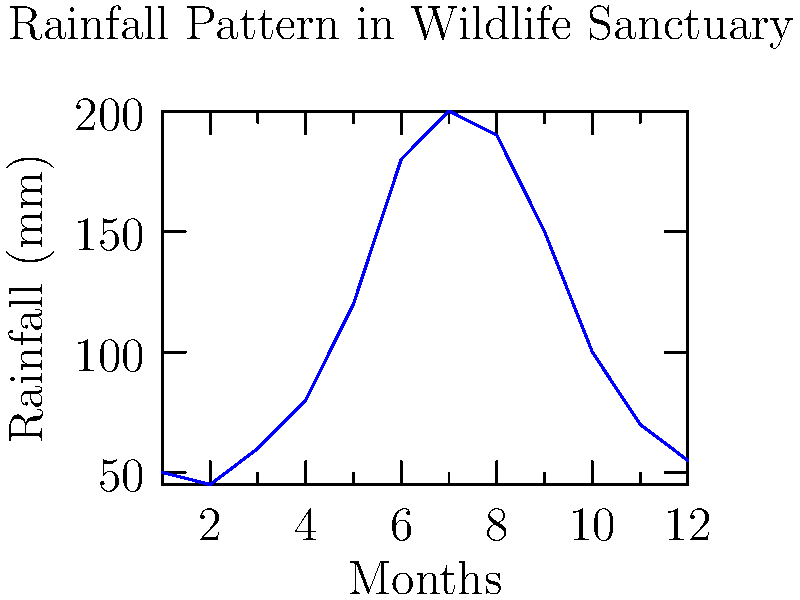Based on the line graph showing the rainfall pattern in the wildlife sanctuary, during which month does the sanctuary experience the highest rainfall? How might this peak rainfall affect the wildlife and ecosystem management strategies? To answer this question, we need to follow these steps:

1. Examine the line graph carefully, focusing on the y-axis (Rainfall in mm) and the x-axis (Months).

2. Identify the highest point on the graph, which represents the month with the maximum rainfall.

3. The graph shows that the rainfall increases steadily from month 1 (January) to month 7 (July), then starts decreasing.

4. The highest point on the graph corresponds to month 7 (July), with a rainfall of approximately 200 mm.

5. Consider the implications of peak rainfall:
   a) Increased water availability for plants and animals
   b) Potential for flooding in low-lying areas
   c) Changes in animal behavior or migration patterns
   d) Need for water management strategies (e.g., drainage systems)
   e) Possible erosion and soil management concerns

6. Ecosystem management strategies might include:
   a) Implementing flood control measures
   b) Monitoring wildlife populations and behavior
   c) Assessing and maintaining habitat quality
   d) Developing water conservation plans for drier months
Answer: July; impacts include increased water availability, potential flooding, changes in wildlife behavior, and need for adapted management strategies. 